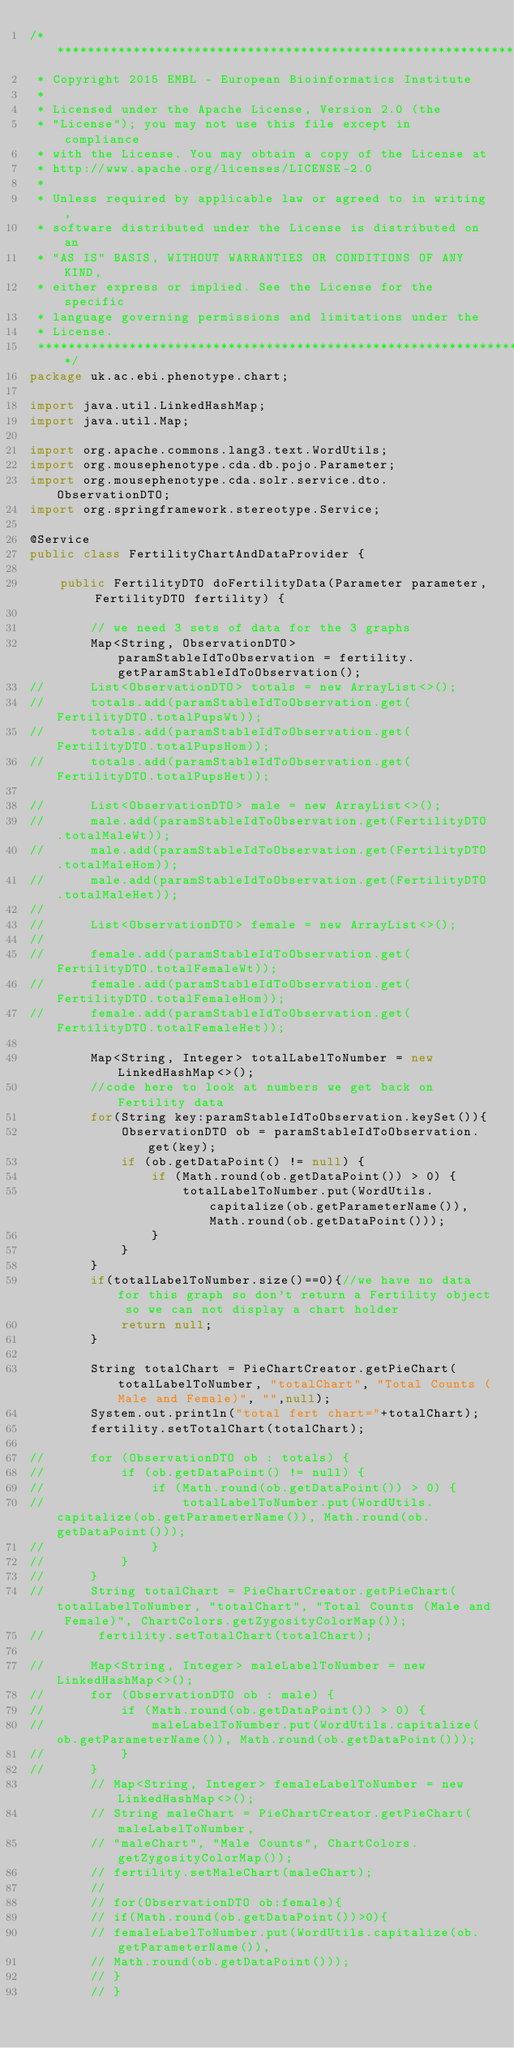Convert code to text. <code><loc_0><loc_0><loc_500><loc_500><_Java_>/*******************************************************************************
 * Copyright 2015 EMBL - European Bioinformatics Institute
 *
 * Licensed under the Apache License, Version 2.0 (the
 * "License"); you may not use this file except in compliance
 * with the License. You may obtain a copy of the License at
 * http://www.apache.org/licenses/LICENSE-2.0
 *
 * Unless required by applicable law or agreed to in writing,
 * software distributed under the License is distributed on an
 * "AS IS" BASIS, WITHOUT WARRANTIES OR CONDITIONS OF ANY KIND,
 * either express or implied. See the License for the specific
 * language governing permissions and limitations under the
 * License.
 *******************************************************************************/
package uk.ac.ebi.phenotype.chart;

import java.util.LinkedHashMap;
import java.util.Map;

import org.apache.commons.lang3.text.WordUtils;
import org.mousephenotype.cda.db.pojo.Parameter;
import org.mousephenotype.cda.solr.service.dto.ObservationDTO;
import org.springframework.stereotype.Service;

@Service
public class FertilityChartAndDataProvider {

	public FertilityDTO doFertilityData(Parameter parameter, FertilityDTO fertility) {

		// we need 3 sets of data for the 3 graphs
		Map<String, ObservationDTO> paramStableIdToObservation = fertility.getParamStableIdToObservation();
//		List<ObservationDTO> totals = new ArrayList<>();
//		totals.add(paramStableIdToObservation.get(FertilityDTO.totalPupsWt));
//		totals.add(paramStableIdToObservation.get(FertilityDTO.totalPupsHom));
//		totals.add(paramStableIdToObservation.get(FertilityDTO.totalPupsHet));

//		List<ObservationDTO> male = new ArrayList<>();
//		male.add(paramStableIdToObservation.get(FertilityDTO.totalMaleWt));
//		male.add(paramStableIdToObservation.get(FertilityDTO.totalMaleHom));
//		male.add(paramStableIdToObservation.get(FertilityDTO.totalMaleHet));
//
//		List<ObservationDTO> female = new ArrayList<>();
//
//		female.add(paramStableIdToObservation.get(FertilityDTO.totalFemaleWt));
//		female.add(paramStableIdToObservation.get(FertilityDTO.totalFemaleHom));
//		female.add(paramStableIdToObservation.get(FertilityDTO.totalFemaleHet));

		Map<String, Integer> totalLabelToNumber = new LinkedHashMap<>();
		//code here to look at numbers we get back on Fertility data
		for(String key:paramStableIdToObservation.keySet()){
			ObservationDTO ob = paramStableIdToObservation.get(key);
			if (ob.getDataPoint() != null) {
				if (Math.round(ob.getDataPoint()) > 0) {
					totalLabelToNumber.put(WordUtils.capitalize(ob.getParameterName()), Math.round(ob.getDataPoint()));
				}
			}
		}
		if(totalLabelToNumber.size()==0){//we have no data for this graph so don't return a Fertility object so we can not display a chart holder
			return null;
		}

		String totalChart = PieChartCreator.getPieChart(totalLabelToNumber, "totalChart", "Total Counts (Male and Female)", "",null);
		System.out.println("total fert chart="+totalChart);
		fertility.setTotalChart(totalChart);

//		for (ObservationDTO ob : totals) {
//			if (ob.getDataPoint() != null) {
//				if (Math.round(ob.getDataPoint()) > 0) {
//					totalLabelToNumber.put(WordUtils.capitalize(ob.getParameterName()), Math.round(ob.getDataPoint()));
//				}
//			}
//		}
//		String totalChart = PieChartCreator.getPieChart(totalLabelToNumber, "totalChart", "Total Counts (Male and Female)", ChartColors.getZygosityColorMap());
//		 fertility.setTotalChart(totalChart);

//		Map<String, Integer> maleLabelToNumber = new LinkedHashMap<>();
//		for (ObservationDTO ob : male) {
//			if (Math.round(ob.getDataPoint()) > 0) {
//				maleLabelToNumber.put(WordUtils.capitalize(ob.getParameterName()), Math.round(ob.getDataPoint()));
//			}
//		}
		// Map<String, Integer> femaleLabelToNumber = new LinkedHashMap<>();
		// String maleChart = PieChartCreator.getPieChart(maleLabelToNumber,
		// "maleChart", "Male Counts", ChartColors.getZygosityColorMap());
		// fertility.setMaleChart(maleChart);
		//
		// for(ObservationDTO ob:female){
		// if(Math.round(ob.getDataPoint())>0){
		// femaleLabelToNumber.put(WordUtils.capitalize(ob.getParameterName()),
		// Math.round(ob.getDataPoint()));
		// }
		// }</code> 